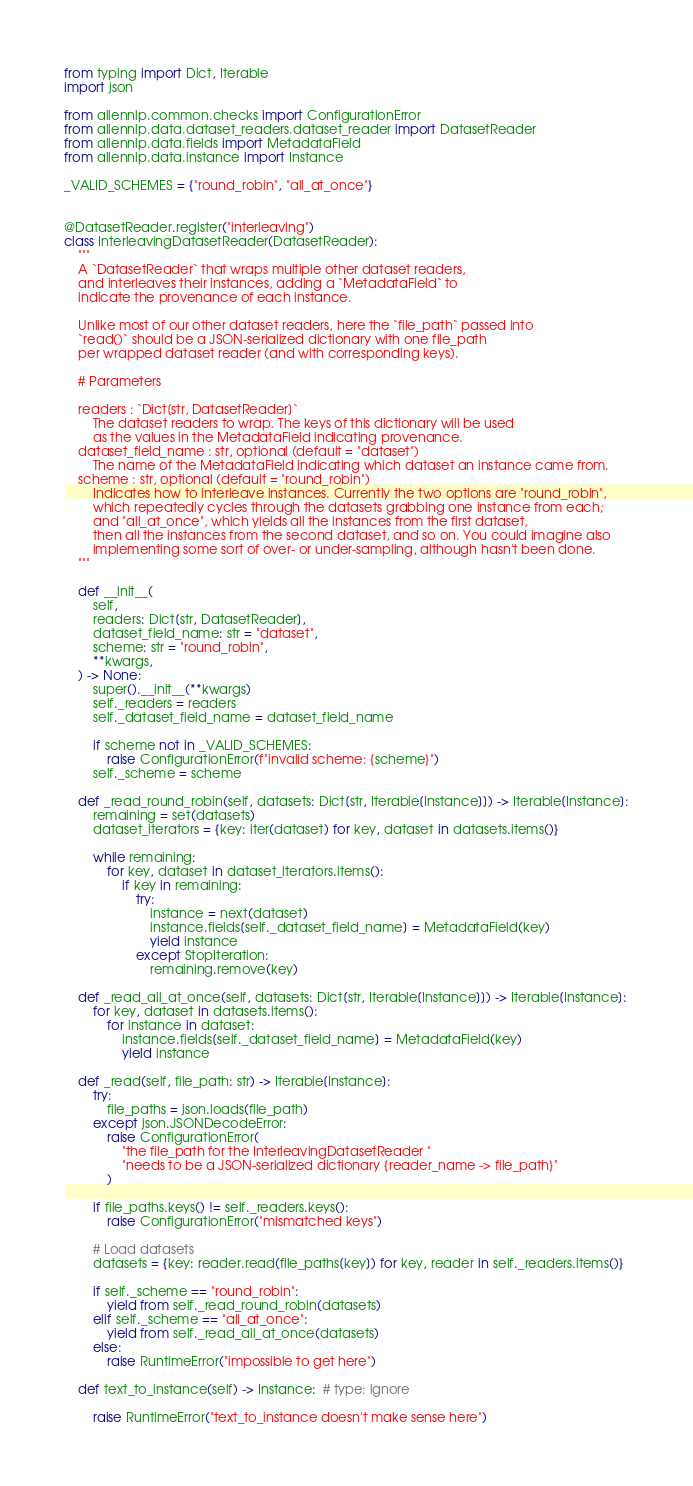<code> <loc_0><loc_0><loc_500><loc_500><_Python_>from typing import Dict, Iterable
import json

from allennlp.common.checks import ConfigurationError
from allennlp.data.dataset_readers.dataset_reader import DatasetReader
from allennlp.data.fields import MetadataField
from allennlp.data.instance import Instance

_VALID_SCHEMES = {"round_robin", "all_at_once"}


@DatasetReader.register("interleaving")
class InterleavingDatasetReader(DatasetReader):
    """
    A `DatasetReader` that wraps multiple other dataset readers,
    and interleaves their instances, adding a `MetadataField` to
    indicate the provenance of each instance.

    Unlike most of our other dataset readers, here the `file_path` passed into
    `read()` should be a JSON-serialized dictionary with one file_path
    per wrapped dataset reader (and with corresponding keys).

    # Parameters

    readers : `Dict[str, DatasetReader]`
        The dataset readers to wrap. The keys of this dictionary will be used
        as the values in the MetadataField indicating provenance.
    dataset_field_name : str, optional (default = "dataset")
        The name of the MetadataField indicating which dataset an instance came from.
    scheme : str, optional (default = "round_robin")
        Indicates how to interleave instances. Currently the two options are "round_robin",
        which repeatedly cycles through the datasets grabbing one instance from each;
        and "all_at_once", which yields all the instances from the first dataset,
        then all the instances from the second dataset, and so on. You could imagine also
        implementing some sort of over- or under-sampling, although hasn't been done.
    """

    def __init__(
        self,
        readers: Dict[str, DatasetReader],
        dataset_field_name: str = "dataset",
        scheme: str = "round_robin",
        **kwargs,
    ) -> None:
        super().__init__(**kwargs)
        self._readers = readers
        self._dataset_field_name = dataset_field_name

        if scheme not in _VALID_SCHEMES:
            raise ConfigurationError(f"invalid scheme: {scheme}")
        self._scheme = scheme

    def _read_round_robin(self, datasets: Dict[str, Iterable[Instance]]) -> Iterable[Instance]:
        remaining = set(datasets)
        dataset_iterators = {key: iter(dataset) for key, dataset in datasets.items()}

        while remaining:
            for key, dataset in dataset_iterators.items():
                if key in remaining:
                    try:
                        instance = next(dataset)
                        instance.fields[self._dataset_field_name] = MetadataField(key)
                        yield instance
                    except StopIteration:
                        remaining.remove(key)

    def _read_all_at_once(self, datasets: Dict[str, Iterable[Instance]]) -> Iterable[Instance]:
        for key, dataset in datasets.items():
            for instance in dataset:
                instance.fields[self._dataset_field_name] = MetadataField(key)
                yield instance

    def _read(self, file_path: str) -> Iterable[Instance]:
        try:
            file_paths = json.loads(file_path)
        except json.JSONDecodeError:
            raise ConfigurationError(
                "the file_path for the InterleavingDatasetReader "
                "needs to be a JSON-serialized dictionary {reader_name -> file_path}"
            )

        if file_paths.keys() != self._readers.keys():
            raise ConfigurationError("mismatched keys")

        # Load datasets
        datasets = {key: reader.read(file_paths[key]) for key, reader in self._readers.items()}

        if self._scheme == "round_robin":
            yield from self._read_round_robin(datasets)
        elif self._scheme == "all_at_once":
            yield from self._read_all_at_once(datasets)
        else:
            raise RuntimeError("impossible to get here")

    def text_to_instance(self) -> Instance:  # type: ignore

        raise RuntimeError("text_to_instance doesn't make sense here")
</code> 